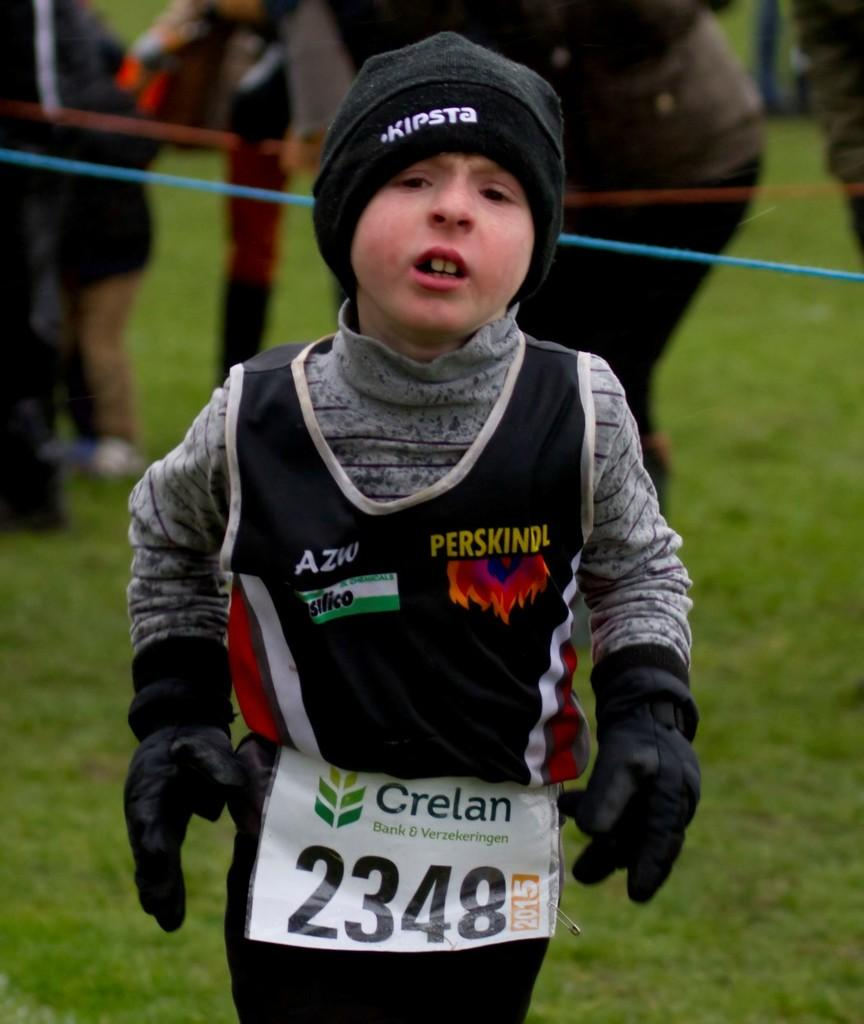What is the main subject in the foreground of the image? There is a boy in the foreground of the image. What is on the boy in the image? There is a poster on the boy. What can be seen in the background of the image? There is a group of people in the background of the image. What objects are visible that might be used for tying or securing? There are ropes visible in the image. What type of ground surface is present at the bottom of the image? There is grass at the bottom of the image. Can you tell me how many seeds are visible in the image? There are no seeds present in the image. What type of flight is the boy taking in the image? The boy is not taking any flight in the image; he is standing on the ground. 